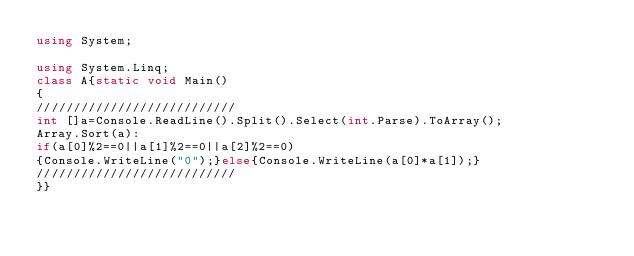<code> <loc_0><loc_0><loc_500><loc_500><_C#_>using System;

using System.Linq;
class A{static void Main()
{
///////////////////////////
int []a=Console.ReadLine().Split().Select(int.Parse).ToArray();
Array.Sort(a):
if(a[0]%2==0||a[1]%2==0||a[2]%2==0)
{Console.WriteLine("0");}else{Console.WriteLine(a[0]*a[1]);}
///////////////////////////
}}</code> 